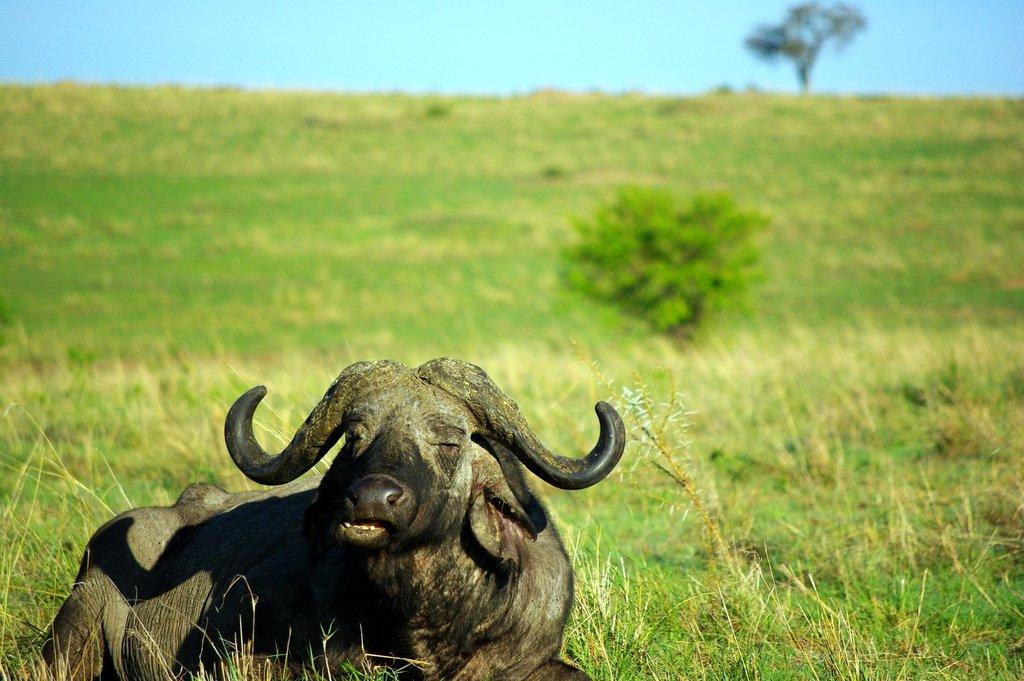What type of animal is in the foreground of the image? There is an animal in the foreground of the image, but the specific type cannot be determined from the facts provided. What is at the bottom of the image? There is grass at the bottom of the image. What can be seen in the background of the image? There are trees in the background of the image. What is visible at the top of the image? The sky is visible at the top of the image. What is the title of the book that the dinosaurs are reading in the image? There are no dinosaurs or books present in the image, so there is no title to be determined. 